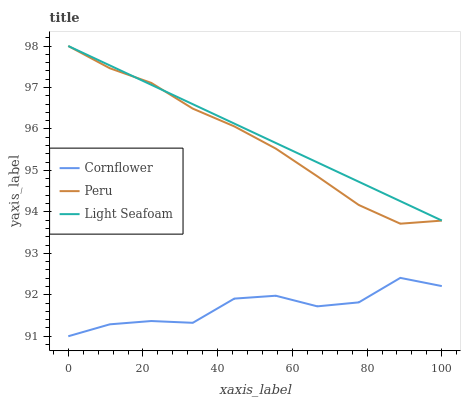Does Cornflower have the minimum area under the curve?
Answer yes or no. Yes. Does Light Seafoam have the maximum area under the curve?
Answer yes or no. Yes. Does Peru have the minimum area under the curve?
Answer yes or no. No. Does Peru have the maximum area under the curve?
Answer yes or no. No. Is Light Seafoam the smoothest?
Answer yes or no. Yes. Is Cornflower the roughest?
Answer yes or no. Yes. Is Peru the smoothest?
Answer yes or no. No. Is Peru the roughest?
Answer yes or no. No. Does Cornflower have the lowest value?
Answer yes or no. Yes. Does Peru have the lowest value?
Answer yes or no. No. Does Peru have the highest value?
Answer yes or no. Yes. Is Cornflower less than Peru?
Answer yes or no. Yes. Is Peru greater than Cornflower?
Answer yes or no. Yes. Does Light Seafoam intersect Peru?
Answer yes or no. Yes. Is Light Seafoam less than Peru?
Answer yes or no. No. Is Light Seafoam greater than Peru?
Answer yes or no. No. Does Cornflower intersect Peru?
Answer yes or no. No. 